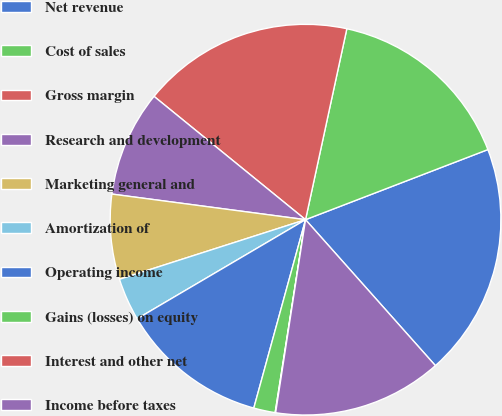Convert chart. <chart><loc_0><loc_0><loc_500><loc_500><pie_chart><fcel>Net revenue<fcel>Cost of sales<fcel>Gross margin<fcel>Research and development<fcel>Marketing general and<fcel>Amortization of<fcel>Operating income<fcel>Gains (losses) on equity<fcel>Interest and other net<fcel>Income before taxes<nl><fcel>19.27%<fcel>15.77%<fcel>17.52%<fcel>8.78%<fcel>7.03%<fcel>3.53%<fcel>12.27%<fcel>1.78%<fcel>0.04%<fcel>14.02%<nl></chart> 